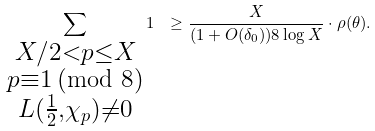Convert formula to latex. <formula><loc_0><loc_0><loc_500><loc_500>\sum _ { \substack { X / 2 < p \leq X \\ p \equiv 1 \, ( \text {mod } 8 ) \\ L ( \frac { 1 } { 2 } , \chi _ { p } ) \neq 0 } } 1 \ & \geq \frac { X } { ( 1 + O ( \delta _ { 0 } ) ) 8 \log X } \cdot \rho ( \theta ) .</formula> 